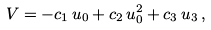<formula> <loc_0><loc_0><loc_500><loc_500>V = - c _ { 1 } \, u _ { 0 } + c _ { 2 } \, u _ { 0 } ^ { 2 } + c _ { 3 } \, u _ { 3 } \, ,</formula> 